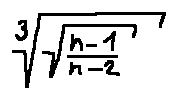Convert formula to latex. <formula><loc_0><loc_0><loc_500><loc_500>\sqrt { [ } 3 ] { \sqrt { \frac { n - 1 } { n - 2 } } }</formula> 